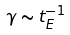Convert formula to latex. <formula><loc_0><loc_0><loc_500><loc_500>\gamma \sim t _ { E } ^ { - 1 }</formula> 